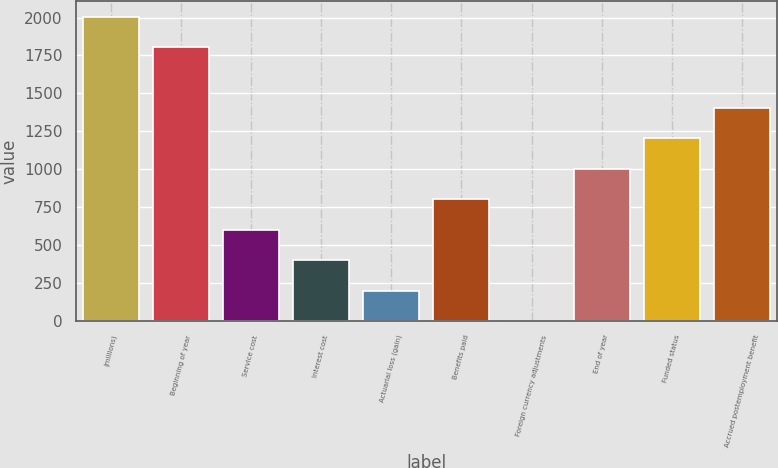<chart> <loc_0><loc_0><loc_500><loc_500><bar_chart><fcel>(millions)<fcel>Beginning of year<fcel>Service cost<fcel>Interest cost<fcel>Actuarial loss (gain)<fcel>Benefits paid<fcel>Foreign currency adjustments<fcel>End of year<fcel>Funded status<fcel>Accrued postemployment benefit<nl><fcel>2006<fcel>1805.44<fcel>602.08<fcel>401.52<fcel>200.96<fcel>802.64<fcel>0.4<fcel>1003.2<fcel>1203.76<fcel>1404.32<nl></chart> 